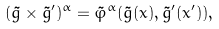Convert formula to latex. <formula><loc_0><loc_0><loc_500><loc_500>( \tilde { g } \times \tilde { g } ^ { \prime } ) ^ { \alpha } = \tilde { \varphi } ^ { \alpha } ( \tilde { g } ( x ) , \tilde { g } ^ { \prime } ( x ^ { \prime } ) ) , \,</formula> 